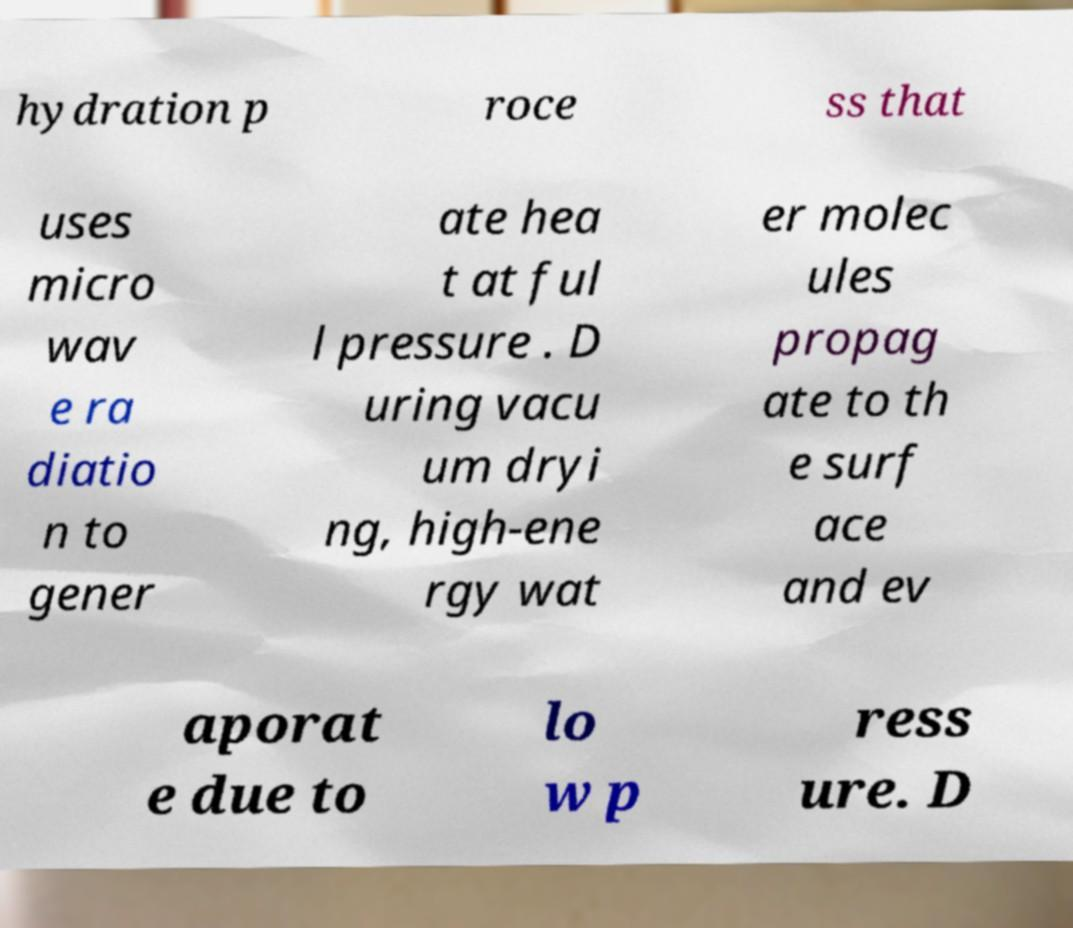Please read and relay the text visible in this image. What does it say? hydration p roce ss that uses micro wav e ra diatio n to gener ate hea t at ful l pressure . D uring vacu um dryi ng, high-ene rgy wat er molec ules propag ate to th e surf ace and ev aporat e due to lo w p ress ure. D 